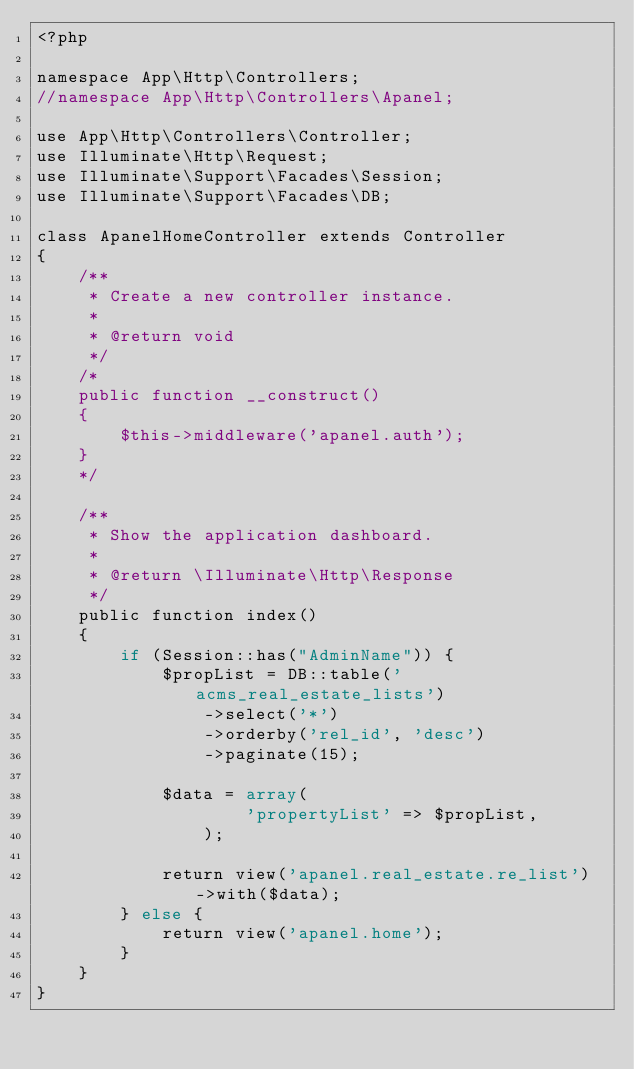Convert code to text. <code><loc_0><loc_0><loc_500><loc_500><_PHP_><?php

namespace App\Http\Controllers;
//namespace App\Http\Controllers\Apanel;

use App\Http\Controllers\Controller;
use Illuminate\Http\Request;
use Illuminate\Support\Facades\Session;
use Illuminate\Support\Facades\DB;

class ApanelHomeController extends Controller
{
    /**
     * Create a new controller instance.
     *
     * @return void
     */
    /*
    public function __construct()
    {
        $this->middleware('apanel.auth');
    }
    */

    /**
     * Show the application dashboard.
     *
     * @return \Illuminate\Http\Response
     */
    public function index()
    {
        if (Session::has("AdminName")) {
            $propList = DB::table('acms_real_estate_lists')
                ->select('*')
                ->orderby('rel_id', 'desc')
                ->paginate(15);
            
            $data = array(
                    'propertyList' => $propList,
                );

            return view('apanel.real_estate.re_list')->with($data);
        } else {
            return view('apanel.home');
        }
    }
}
</code> 